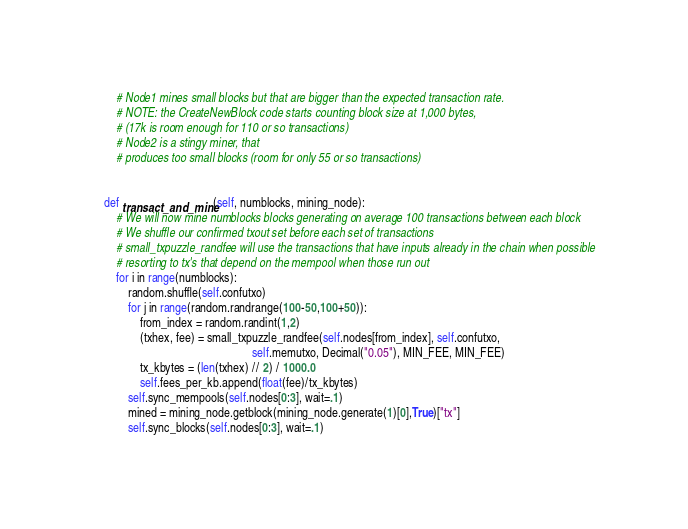Convert code to text. <code><loc_0><loc_0><loc_500><loc_500><_Python_>        # Node1 mines small blocks but that are bigger than the expected transaction rate.
        # NOTE: the CreateNewBlock code starts counting block size at 1,000 bytes,
        # (17k is room enough for 110 or so transactions)
        # Node2 is a stingy miner, that
        # produces too small blocks (room for only 55 or so transactions)


    def transact_and_mine(self, numblocks, mining_node):
        # We will now mine numblocks blocks generating on average 100 transactions between each block
        # We shuffle our confirmed txout set before each set of transactions
        # small_txpuzzle_randfee will use the transactions that have inputs already in the chain when possible
        # resorting to tx's that depend on the mempool when those run out
        for i in range(numblocks):
            random.shuffle(self.confutxo)
            for j in range(random.randrange(100-50,100+50)):
                from_index = random.randint(1,2)
                (txhex, fee) = small_txpuzzle_randfee(self.nodes[from_index], self.confutxo,
                                                      self.memutxo, Decimal("0.05"), MIN_FEE, MIN_FEE)
                tx_kbytes = (len(txhex) // 2) / 1000.0
                self.fees_per_kb.append(float(fee)/tx_kbytes)
            self.sync_mempools(self.nodes[0:3], wait=.1)
            mined = mining_node.getblock(mining_node.generate(1)[0],True)["tx"]
            self.sync_blocks(self.nodes[0:3], wait=.1)</code> 